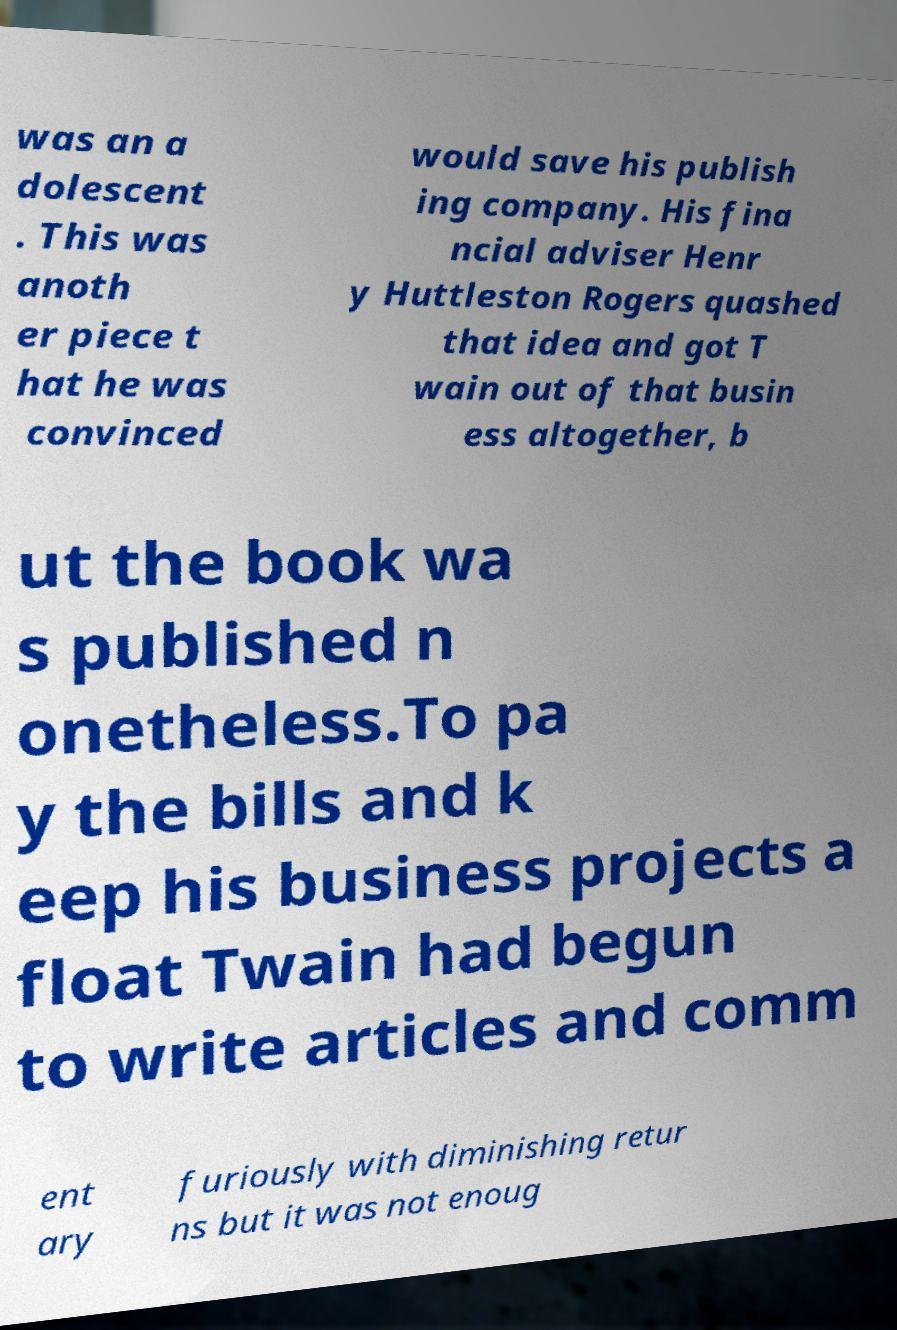Could you assist in decoding the text presented in this image and type it out clearly? was an a dolescent . This was anoth er piece t hat he was convinced would save his publish ing company. His fina ncial adviser Henr y Huttleston Rogers quashed that idea and got T wain out of that busin ess altogether, b ut the book wa s published n onetheless.To pa y the bills and k eep his business projects a float Twain had begun to write articles and comm ent ary furiously with diminishing retur ns but it was not enoug 